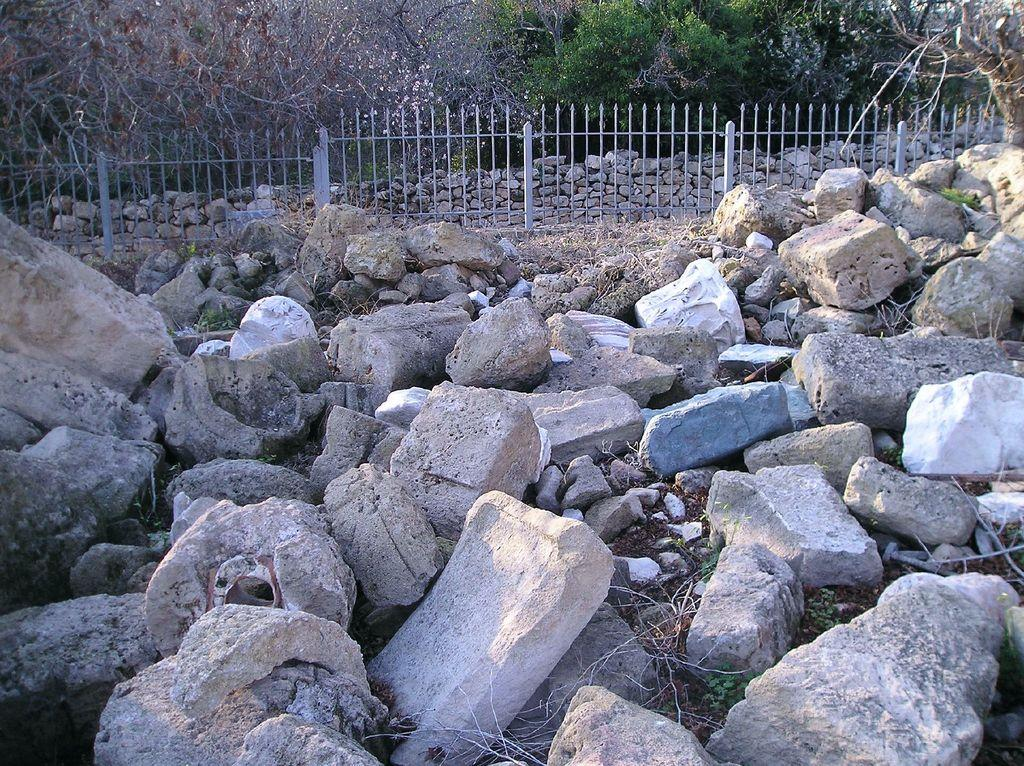What is present at the bottom of the picture? There are stones and rocks, as well as grass, at the bottom of the picture. What can be seen in the middle of the image? There is a fence in the middle of the image. What is located behind the fence? There are rocks or stones behind the fence. What type of vegetation is visible in the background of the image? There are trees in the background of the image. What type of honey can be seen dripping from the fence in the image? There is no honey present in the image; the fence is surrounded by rocks or stones. 